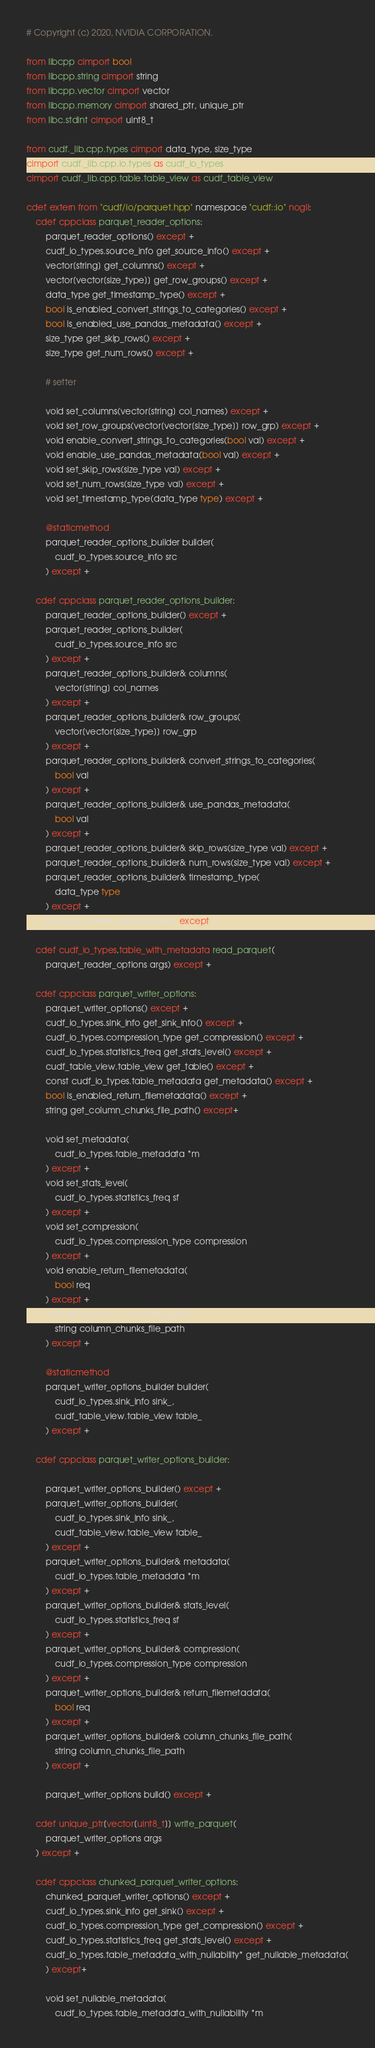<code> <loc_0><loc_0><loc_500><loc_500><_Cython_># Copyright (c) 2020, NVIDIA CORPORATION.

from libcpp cimport bool
from libcpp.string cimport string
from libcpp.vector cimport vector
from libcpp.memory cimport shared_ptr, unique_ptr
from libc.stdint cimport uint8_t

from cudf._lib.cpp.types cimport data_type, size_type
cimport cudf._lib.cpp.io.types as cudf_io_types
cimport cudf._lib.cpp.table.table_view as cudf_table_view

cdef extern from "cudf/io/parquet.hpp" namespace "cudf::io" nogil:
    cdef cppclass parquet_reader_options:
        parquet_reader_options() except +
        cudf_io_types.source_info get_source_info() except +
        vector[string] get_columns() except +
        vector[vector[size_type]] get_row_groups() except +
        data_type get_timestamp_type() except +
        bool is_enabled_convert_strings_to_categories() except +
        bool is_enabled_use_pandas_metadata() except +
        size_type get_skip_rows() except +
        size_type get_num_rows() except +

        # setter

        void set_columns(vector[string] col_names) except +
        void set_row_groups(vector[vector[size_type]] row_grp) except +
        void enable_convert_strings_to_categories(bool val) except +
        void enable_use_pandas_metadata(bool val) except +
        void set_skip_rows(size_type val) except +
        void set_num_rows(size_type val) except +
        void set_timestamp_type(data_type type) except +

        @staticmethod
        parquet_reader_options_builder builder(
            cudf_io_types.source_info src
        ) except +

    cdef cppclass parquet_reader_options_builder:
        parquet_reader_options_builder() except +
        parquet_reader_options_builder(
            cudf_io_types.source_info src
        ) except +
        parquet_reader_options_builder& columns(
            vector[string] col_names
        ) except +
        parquet_reader_options_builder& row_groups(
            vector[vector[size_type]] row_grp
        ) except +
        parquet_reader_options_builder& convert_strings_to_categories(
            bool val
        ) except +
        parquet_reader_options_builder& use_pandas_metadata(
            bool val
        ) except +
        parquet_reader_options_builder& skip_rows(size_type val) except +
        parquet_reader_options_builder& num_rows(size_type val) except +
        parquet_reader_options_builder& timestamp_type(
            data_type type
        ) except +
        parquet_reader_options build() except +

    cdef cudf_io_types.table_with_metadata read_parquet(
        parquet_reader_options args) except +

    cdef cppclass parquet_writer_options:
        parquet_writer_options() except +
        cudf_io_types.sink_info get_sink_info() except +
        cudf_io_types.compression_type get_compression() except +
        cudf_io_types.statistics_freq get_stats_level() except +
        cudf_table_view.table_view get_table() except +
        const cudf_io_types.table_metadata get_metadata() except +
        bool is_enabled_return_filemetadata() except +
        string get_column_chunks_file_path() except+

        void set_metadata(
            cudf_io_types.table_metadata *m
        ) except +
        void set_stats_level(
            cudf_io_types.statistics_freq sf
        ) except +
        void set_compression(
            cudf_io_types.compression_type compression
        ) except +
        void enable_return_filemetadata(
            bool req
        ) except +
        void set_column_chunks_file_path(
            string column_chunks_file_path
        ) except +

        @staticmethod
        parquet_writer_options_builder builder(
            cudf_io_types.sink_info sink_,
            cudf_table_view.table_view table_
        ) except +

    cdef cppclass parquet_writer_options_builder:

        parquet_writer_options_builder() except +
        parquet_writer_options_builder(
            cudf_io_types.sink_info sink_,
            cudf_table_view.table_view table_
        ) except +
        parquet_writer_options_builder& metadata(
            cudf_io_types.table_metadata *m
        ) except +
        parquet_writer_options_builder& stats_level(
            cudf_io_types.statistics_freq sf
        ) except +
        parquet_writer_options_builder& compression(
            cudf_io_types.compression_type compression
        ) except +
        parquet_writer_options_builder& return_filemetadata(
            bool req
        ) except +
        parquet_writer_options_builder& column_chunks_file_path(
            string column_chunks_file_path
        ) except +

        parquet_writer_options build() except +

    cdef unique_ptr[vector[uint8_t]] write_parquet(
        parquet_writer_options args
    ) except +

    cdef cppclass chunked_parquet_writer_options:
        chunked_parquet_writer_options() except +
        cudf_io_types.sink_info get_sink() except +
        cudf_io_types.compression_type get_compression() except +
        cudf_io_types.statistics_freq get_stats_level() except +
        cudf_io_types.table_metadata_with_nullability* get_nullable_metadata(
        ) except+

        void set_nullable_metadata(
            cudf_io_types.table_metadata_with_nullability *m</code> 